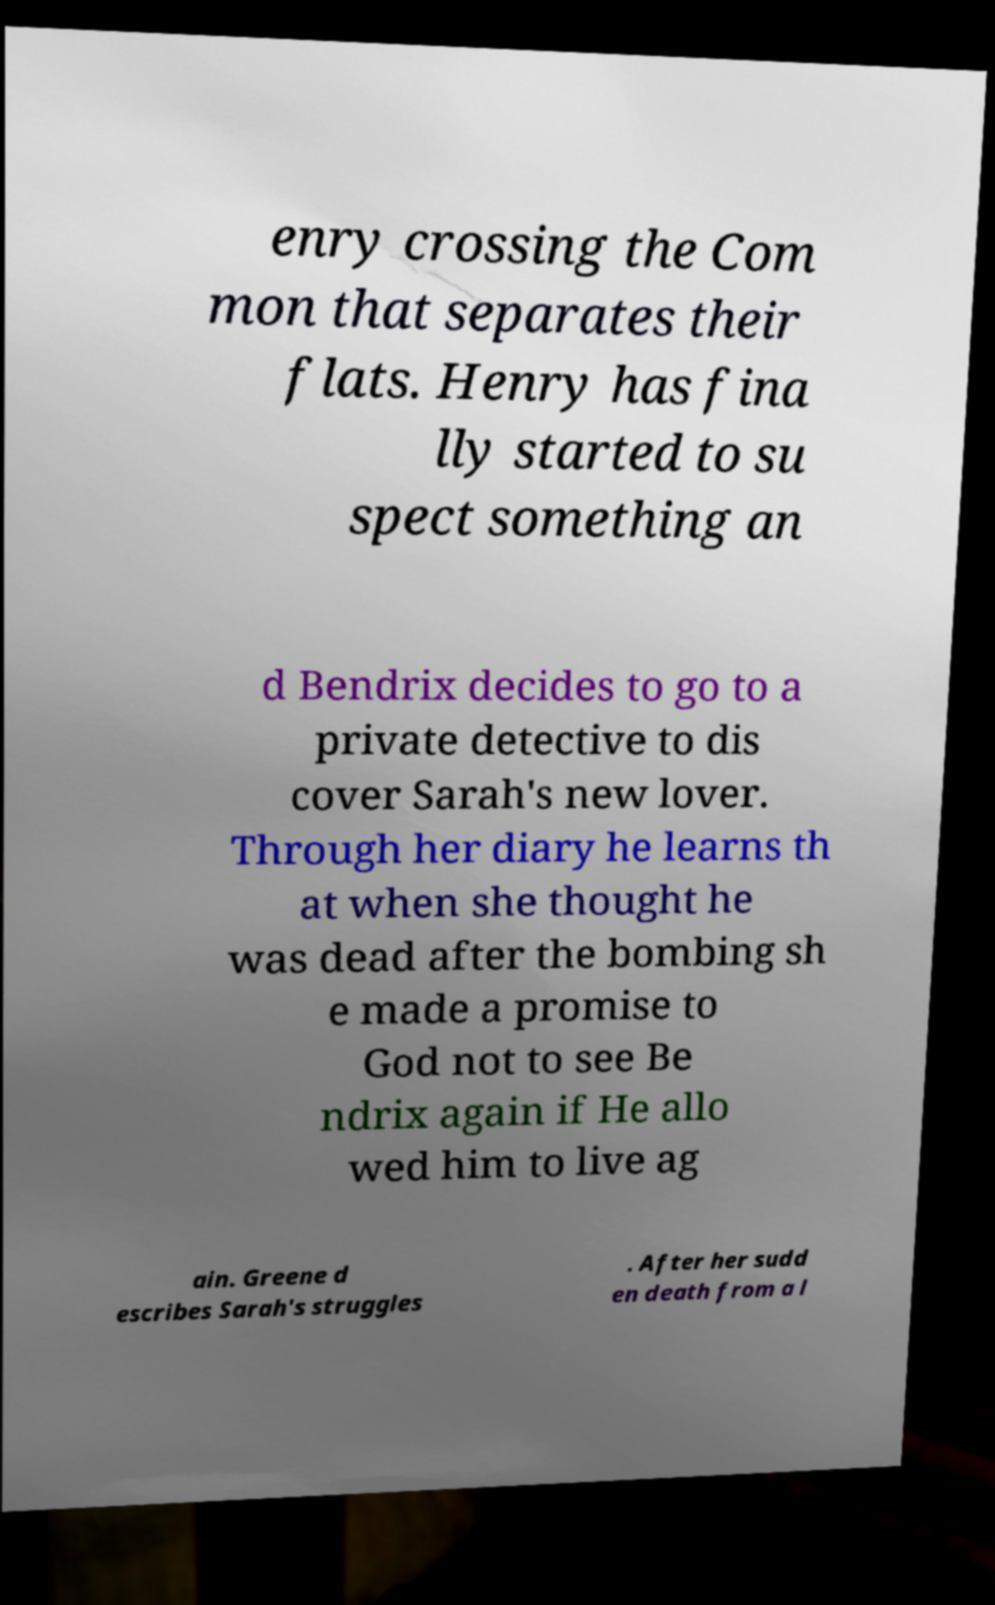What messages or text are displayed in this image? I need them in a readable, typed format. enry crossing the Com mon that separates their flats. Henry has fina lly started to su spect something an d Bendrix decides to go to a private detective to dis cover Sarah's new lover. Through her diary he learns th at when she thought he was dead after the bombing sh e made a promise to God not to see Be ndrix again if He allo wed him to live ag ain. Greene d escribes Sarah's struggles . After her sudd en death from a l 